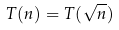Convert formula to latex. <formula><loc_0><loc_0><loc_500><loc_500>T ( n ) = T ( \sqrt { n } )</formula> 